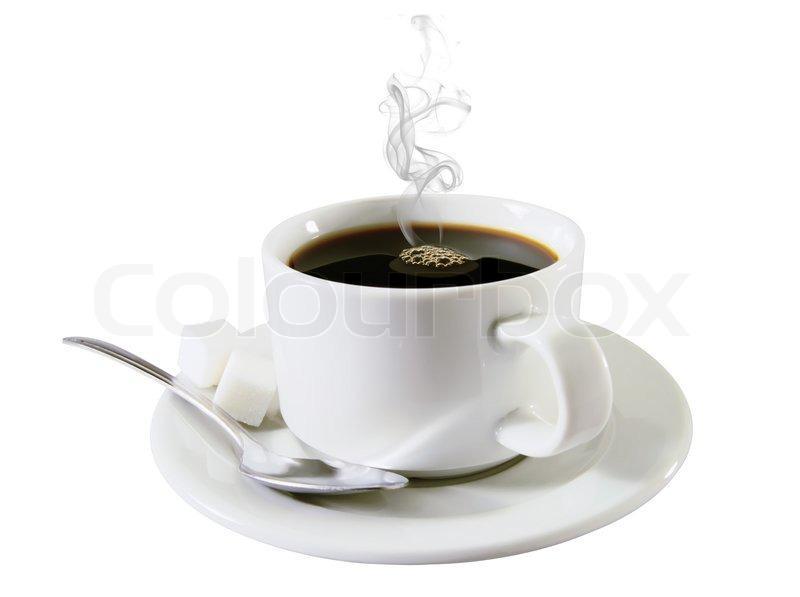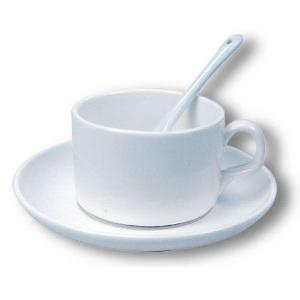The first image is the image on the left, the second image is the image on the right. Given the left and right images, does the statement "Steam is visible in one of the images." hold true? Answer yes or no. Yes. The first image is the image on the left, the second image is the image on the right. Assess this claim about the two images: "In 1 of the images, an empty cup has a spoon in it.". Correct or not? Answer yes or no. Yes. 